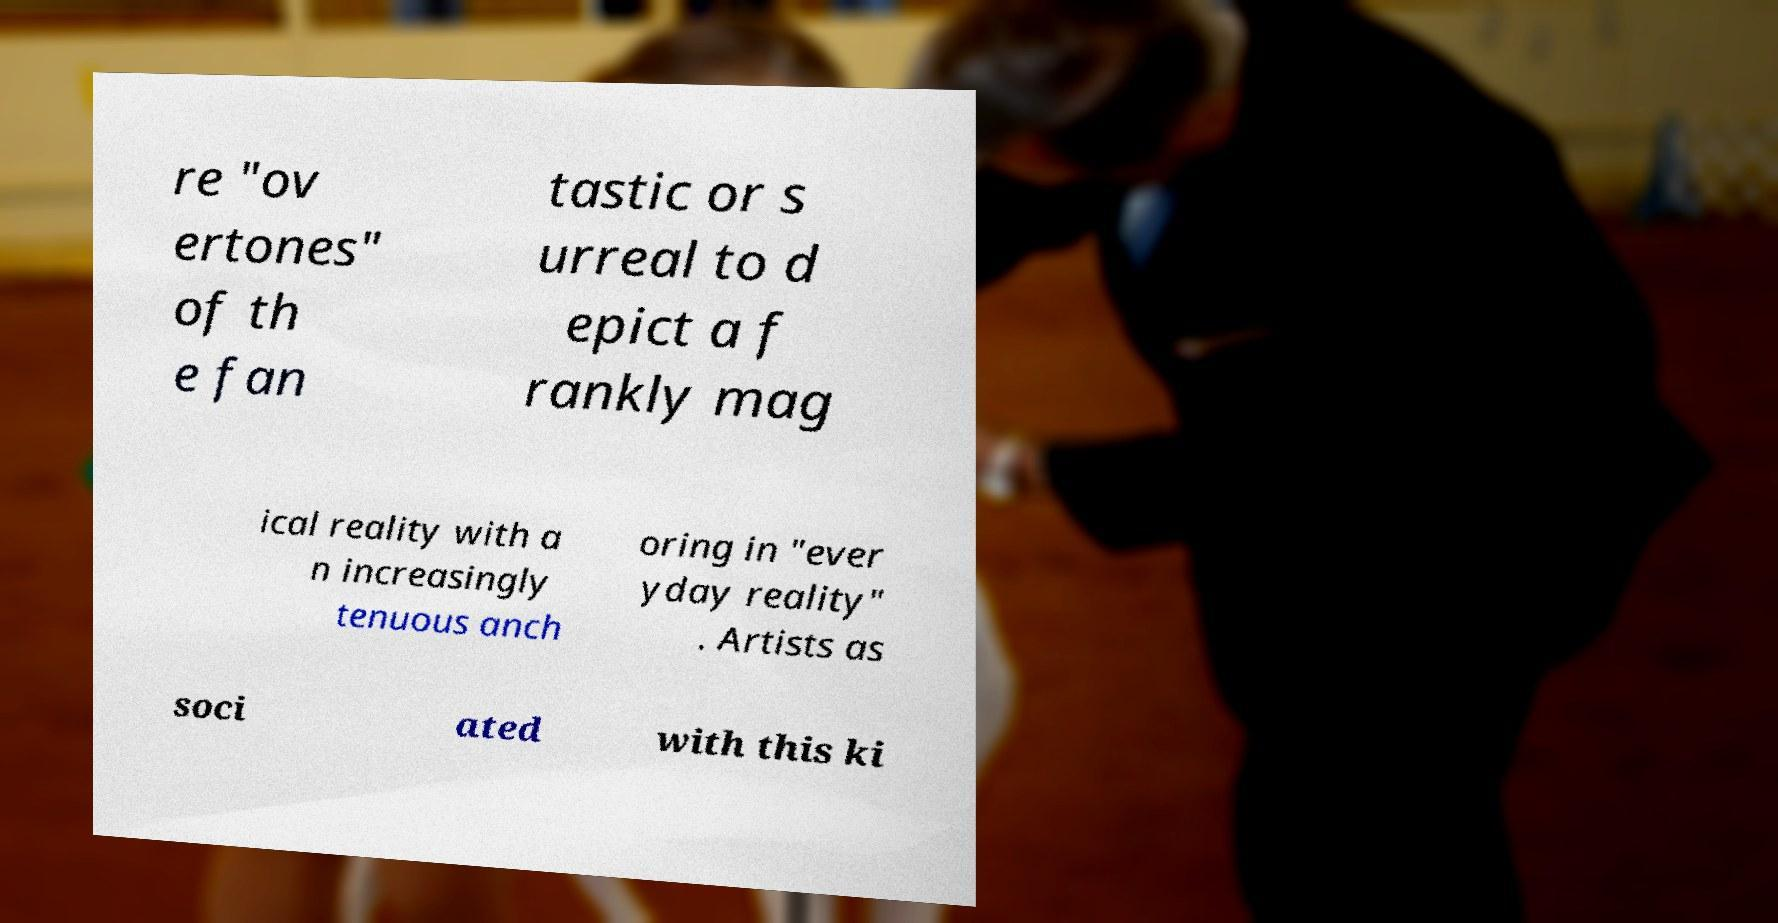I need the written content from this picture converted into text. Can you do that? re "ov ertones" of th e fan tastic or s urreal to d epict a f rankly mag ical reality with a n increasingly tenuous anch oring in "ever yday reality" . Artists as soci ated with this ki 